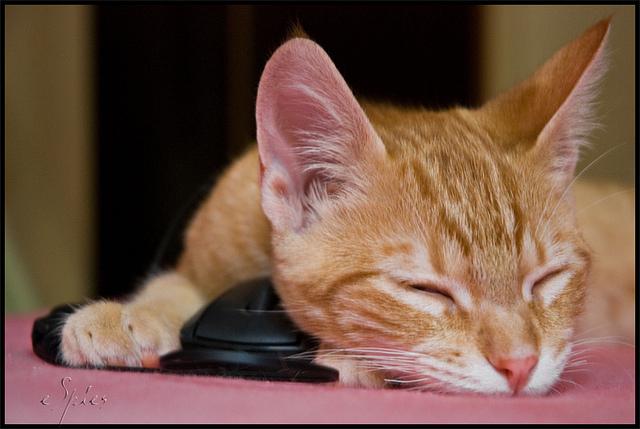What color is the kitten's nose?
Concise answer only. Pink. What color are the insides of the cat's ears?
Give a very brief answer. Pink. What is this cat laying on?
Concise answer only. Mouse. 